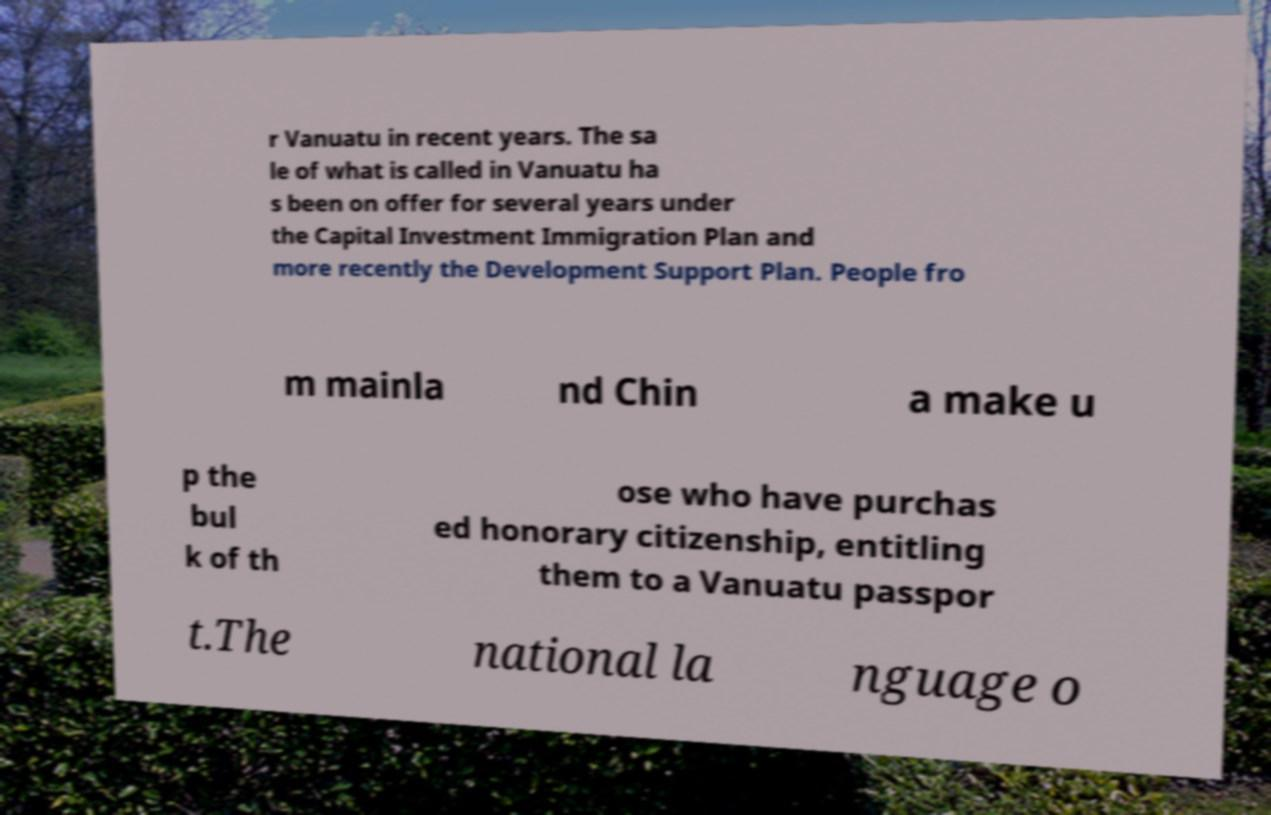I need the written content from this picture converted into text. Can you do that? r Vanuatu in recent years. The sa le of what is called in Vanuatu ha s been on offer for several years under the Capital Investment Immigration Plan and more recently the Development Support Plan. People fro m mainla nd Chin a make u p the bul k of th ose who have purchas ed honorary citizenship, entitling them to a Vanuatu passpor t.The national la nguage o 